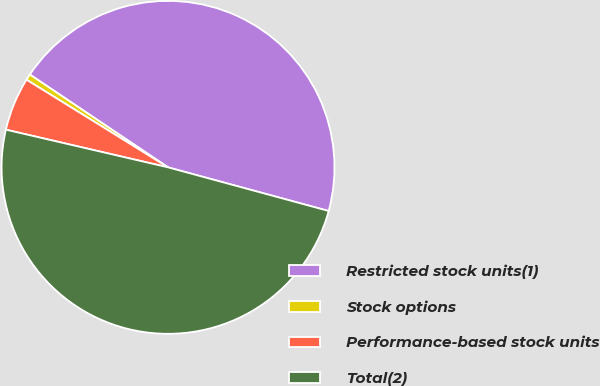<chart> <loc_0><loc_0><loc_500><loc_500><pie_chart><fcel>Restricted stock units(1)<fcel>Stock options<fcel>Performance-based stock units<fcel>Total(2)<nl><fcel>44.81%<fcel>0.59%<fcel>5.19%<fcel>49.41%<nl></chart> 